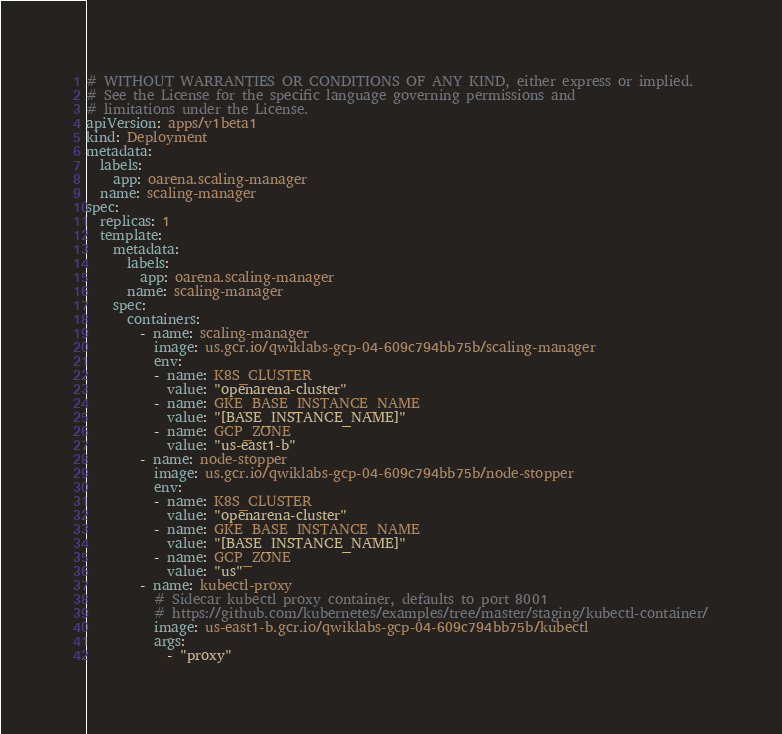<code> <loc_0><loc_0><loc_500><loc_500><_YAML_># WITHOUT WARRANTIES OR CONDITIONS OF ANY KIND, either express or implied.
# See the License for the specific language governing permissions and
# limitations under the License.
apiVersion: apps/v1beta1 
kind: Deployment
metadata:
  labels:
    app: oarena.scaling-manager 
  name: scaling-manager 
spec:
  replicas: 1
  template:
    metadata:
      labels:
        app: oarena.scaling-manager
      name: scaling-manager 
    spec:
      containers:
        - name: scaling-manager 
          image: us.gcr.io/qwiklabs-gcp-04-609c794bb75b/scaling-manager
          env:
          - name: K8S_CLUSTER
            value: "openarena-cluster"
          - name: GKE_BASE_INSTANCE_NAME
            value: "[BASE_INSTANCE_NAME]"
          - name: GCP_ZONE
            value: "us-east1-b"
        - name: node-stopper 
          image: us.gcr.io/qwiklabs-gcp-04-609c794bb75b/node-stopper
          env:
          - name: K8S_CLUSTER
            value: "openarena-cluster"
          - name: GKE_BASE_INSTANCE_NAME
            value: "[BASE_INSTANCE_NAME]"
          - name: GCP_ZONE
            value: "us"
        - name: kubectl-proxy
          # Sidecar kubectl proxy container, defaults to port 8001
          # https://github.com/kubernetes/examples/tree/master/staging/kubectl-container/
          image: us-east1-b.gcr.io/qwiklabs-gcp-04-609c794bb75b/kubectl
          args:
            - "proxy"
</code> 